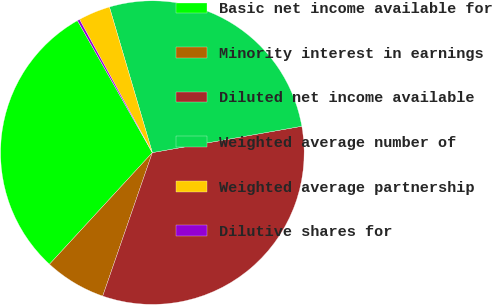<chart> <loc_0><loc_0><loc_500><loc_500><pie_chart><fcel>Basic net income available for<fcel>Minority interest in earnings<fcel>Diluted net income available<fcel>Weighted average number of<fcel>Weighted average partnership<fcel>Dilutive shares for<nl><fcel>29.94%<fcel>6.55%<fcel>33.08%<fcel>26.79%<fcel>3.4%<fcel>0.25%<nl></chart> 